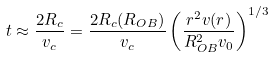Convert formula to latex. <formula><loc_0><loc_0><loc_500><loc_500>t \approx \frac { 2 R _ { c } } { v _ { c } } = \frac { 2 R _ { c } ( R _ { O B } ) } { v _ { c } } \left ( \frac { r ^ { 2 } v ( r ) } { R _ { O B } ^ { 2 } v _ { 0 } } \right ) ^ { 1 / 3 }</formula> 